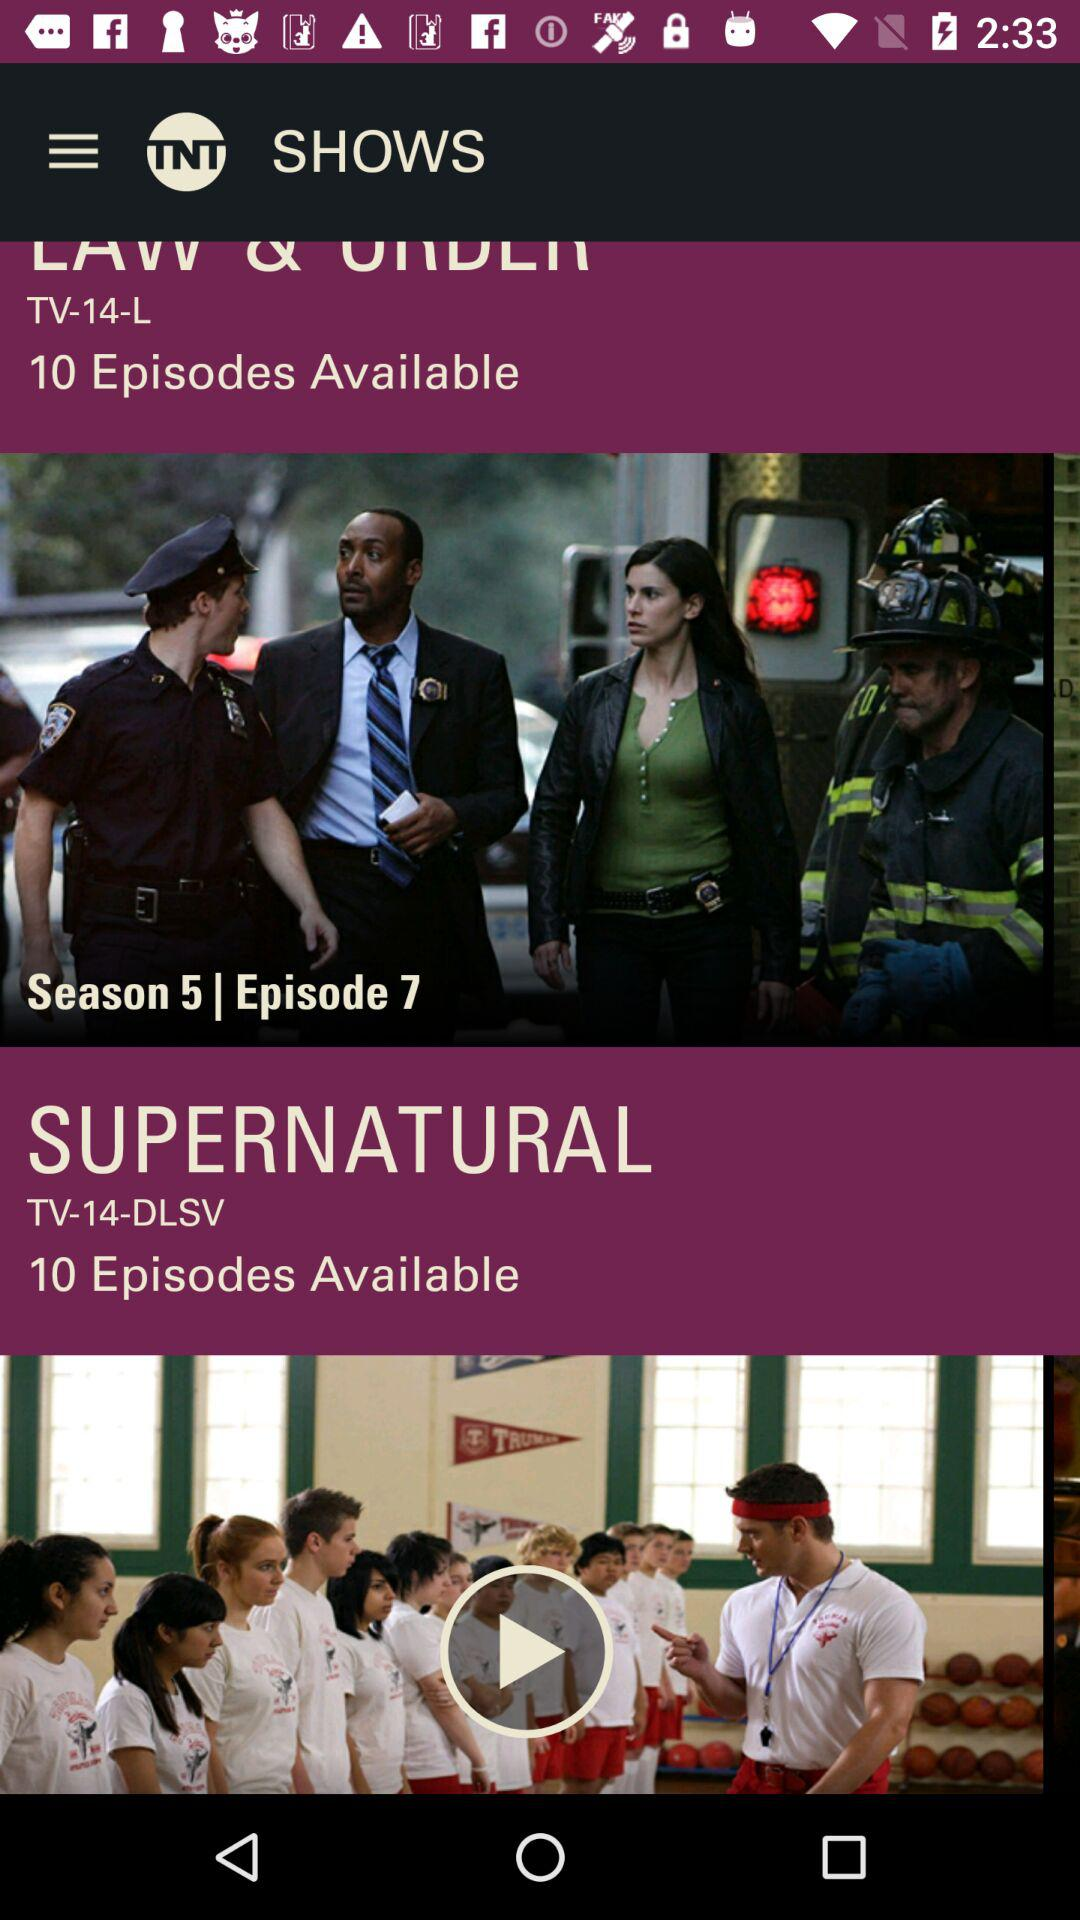How many episodes are available for the show Supernatural?
Answer the question using a single word or phrase. 10 